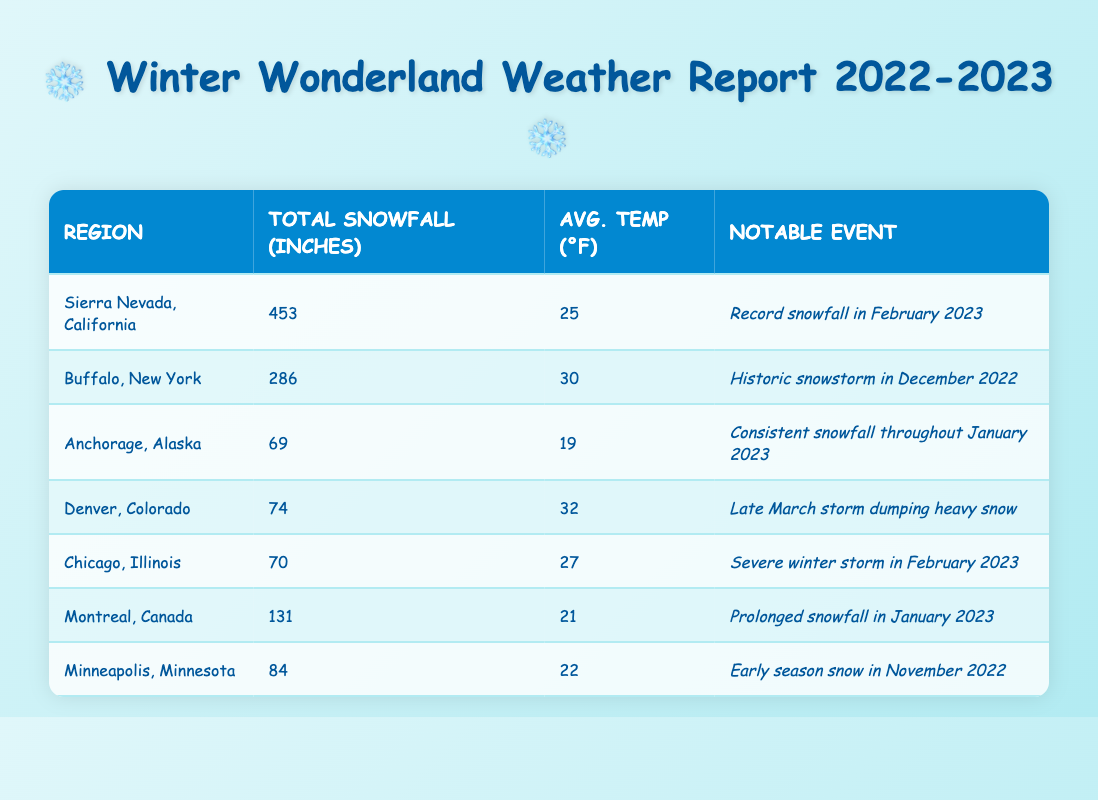What region recorded the highest total snowfall? By scanning the "Total Snowfall (inches)" column, we can see that "Sierra Nevada, California" has the highest value at 453 inches.
Answer: Sierra Nevada, California What was the total snowfall in Buffalo, New York? The table lists the "Total Snowfall (inches)" for Buffalo, New York as 286 inches.
Answer: 286 inches Which region had the lowest average temperature? Looking at the "Avg. Temp (°F)" column, "Anchorage, Alaska" has the lowest average temperature at 19°F.
Answer: Anchorage, Alaska What was the total snowfall in inches for all regions combined? Adding up the total snowfall values: 453 + 286 + 69 + 74 + 70 + 131 + 84 = 1097 inches.
Answer: 1097 inches Did Denver, Colorado, experience a notable snowfall event in February 2023? Checking the notable events for Denver, it states "Late March storm dumping heavy snow." This means it did not experience a notable event in February.
Answer: No Which region had more total snowfall, Montreal, Canada, or Minneapolis, Minnesota? The table reveals that Montreal had 131 inches and Minneapolis had 84 inches. Since 131 is greater than 84, Montreal had more snowfall.
Answer: Montreal, Canada What is the average total snowfall across all regions listed? To find the average, sum the total snowfalls (1097 inches) and divide by the number of regions (7): 1097/7 = 156.71 inches.
Answer: 156.71 inches Was there a record snowfall event in February reported for any region? The table highlights "Record snowfall in February 2023" for Sierra Nevada, California, verifying that there was such an event.
Answer: Yes What is the difference in total snowfall between Sierra Nevada and Chicago, Illinois? From the table, Sierra Nevada has 453 inches and Chicago has 70 inches. The difference is 453 - 70 = 383 inches.
Answer: 383 inches 